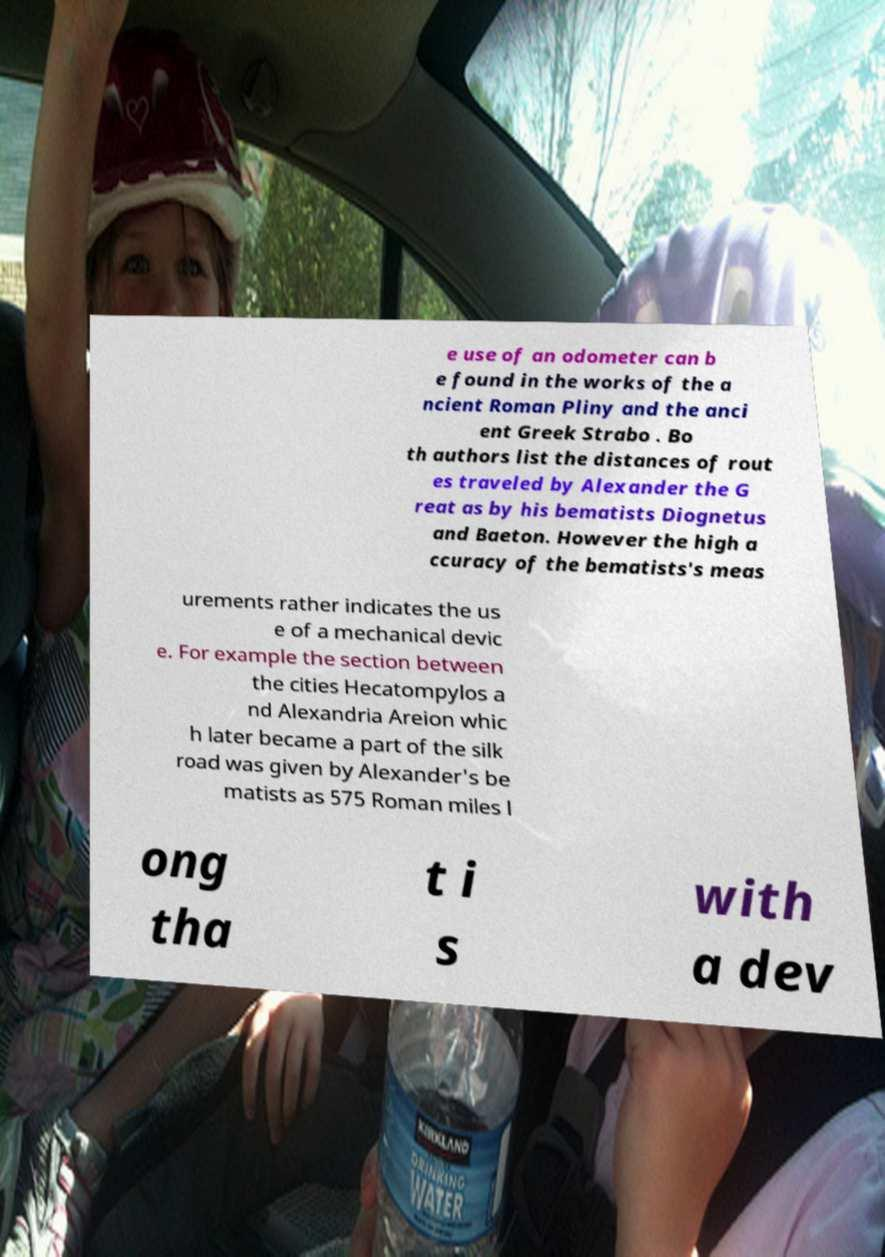Could you extract and type out the text from this image? e use of an odometer can b e found in the works of the a ncient Roman Pliny and the anci ent Greek Strabo . Bo th authors list the distances of rout es traveled by Alexander the G reat as by his bematists Diognetus and Baeton. However the high a ccuracy of the bematists's meas urements rather indicates the us e of a mechanical devic e. For example the section between the cities Hecatompylos a nd Alexandria Areion whic h later became a part of the silk road was given by Alexander's be matists as 575 Roman miles l ong tha t i s with a dev 